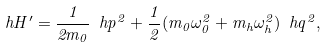Convert formula to latex. <formula><loc_0><loc_0><loc_500><loc_500>\ h H ^ { \prime } = \frac { 1 } { 2 m _ { 0 } } \ h p ^ { 2 } + \frac { 1 } { 2 } ( m _ { 0 } \omega _ { 0 } ^ { 2 } + m _ { h } \omega _ { h } ^ { 2 } ) \ h q ^ { 2 } ,</formula> 